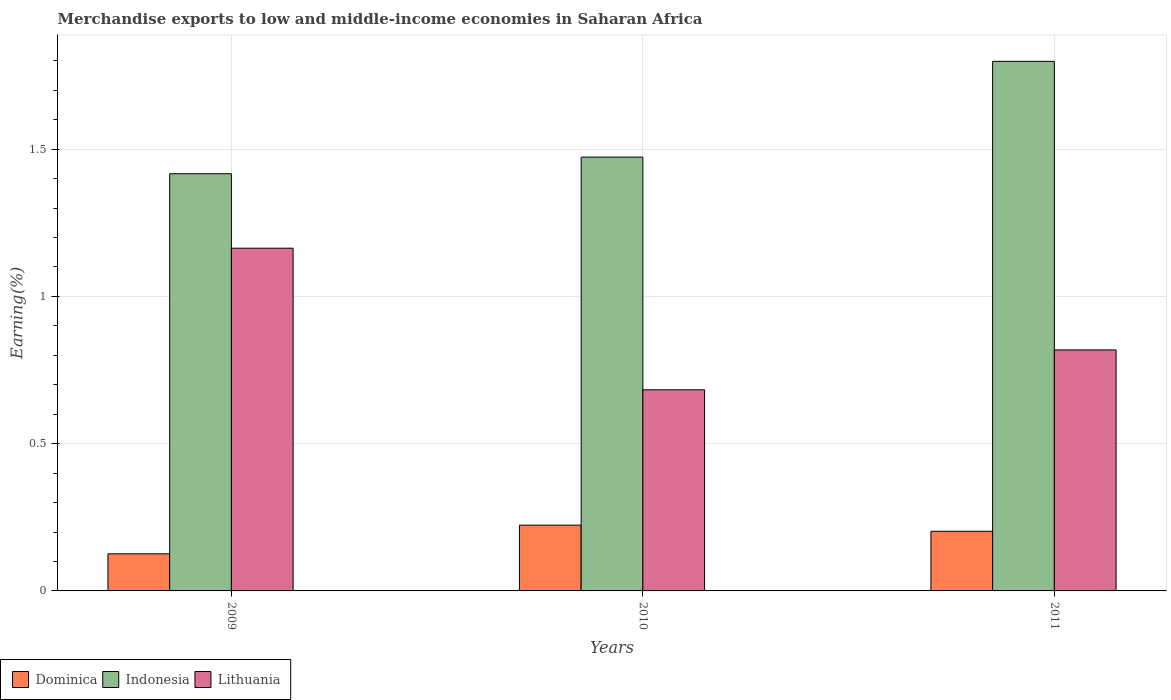How many different coloured bars are there?
Provide a succinct answer. 3. How many groups of bars are there?
Give a very brief answer. 3. Are the number of bars per tick equal to the number of legend labels?
Offer a terse response. Yes. Are the number of bars on each tick of the X-axis equal?
Offer a terse response. Yes. How many bars are there on the 1st tick from the left?
Ensure brevity in your answer.  3. How many bars are there on the 1st tick from the right?
Your answer should be compact. 3. What is the percentage of amount earned from merchandise exports in Indonesia in 2011?
Make the answer very short. 1.8. Across all years, what is the maximum percentage of amount earned from merchandise exports in Indonesia?
Give a very brief answer. 1.8. Across all years, what is the minimum percentage of amount earned from merchandise exports in Lithuania?
Ensure brevity in your answer.  0.68. In which year was the percentage of amount earned from merchandise exports in Indonesia minimum?
Offer a terse response. 2009. What is the total percentage of amount earned from merchandise exports in Lithuania in the graph?
Keep it short and to the point. 2.66. What is the difference between the percentage of amount earned from merchandise exports in Indonesia in 2009 and that in 2010?
Your answer should be compact. -0.06. What is the difference between the percentage of amount earned from merchandise exports in Lithuania in 2011 and the percentage of amount earned from merchandise exports in Indonesia in 2009?
Your answer should be compact. -0.6. What is the average percentage of amount earned from merchandise exports in Lithuania per year?
Offer a terse response. 0.89. In the year 2011, what is the difference between the percentage of amount earned from merchandise exports in Indonesia and percentage of amount earned from merchandise exports in Lithuania?
Your answer should be very brief. 0.98. In how many years, is the percentage of amount earned from merchandise exports in Dominica greater than 1.5 %?
Your answer should be very brief. 0. What is the ratio of the percentage of amount earned from merchandise exports in Dominica in 2010 to that in 2011?
Offer a terse response. 1.1. Is the percentage of amount earned from merchandise exports in Indonesia in 2010 less than that in 2011?
Offer a very short reply. Yes. Is the difference between the percentage of amount earned from merchandise exports in Indonesia in 2009 and 2010 greater than the difference between the percentage of amount earned from merchandise exports in Lithuania in 2009 and 2010?
Your response must be concise. No. What is the difference between the highest and the second highest percentage of amount earned from merchandise exports in Lithuania?
Provide a short and direct response. 0.35. What is the difference between the highest and the lowest percentage of amount earned from merchandise exports in Lithuania?
Offer a terse response. 0.48. Is the sum of the percentage of amount earned from merchandise exports in Lithuania in 2009 and 2010 greater than the maximum percentage of amount earned from merchandise exports in Indonesia across all years?
Give a very brief answer. Yes. What does the 1st bar from the left in 2009 represents?
Keep it short and to the point. Dominica. What does the 3rd bar from the right in 2011 represents?
Keep it short and to the point. Dominica. Does the graph contain any zero values?
Your answer should be compact. No. Where does the legend appear in the graph?
Your answer should be very brief. Bottom left. What is the title of the graph?
Provide a short and direct response. Merchandise exports to low and middle-income economies in Saharan Africa. Does "St. Martin (French part)" appear as one of the legend labels in the graph?
Keep it short and to the point. No. What is the label or title of the Y-axis?
Provide a succinct answer. Earning(%). What is the Earning(%) of Dominica in 2009?
Your response must be concise. 0.13. What is the Earning(%) in Indonesia in 2009?
Give a very brief answer. 1.42. What is the Earning(%) of Lithuania in 2009?
Your answer should be compact. 1.16. What is the Earning(%) in Dominica in 2010?
Provide a short and direct response. 0.22. What is the Earning(%) in Indonesia in 2010?
Keep it short and to the point. 1.47. What is the Earning(%) in Lithuania in 2010?
Provide a short and direct response. 0.68. What is the Earning(%) in Dominica in 2011?
Your answer should be very brief. 0.2. What is the Earning(%) of Indonesia in 2011?
Your response must be concise. 1.8. What is the Earning(%) of Lithuania in 2011?
Your answer should be compact. 0.82. Across all years, what is the maximum Earning(%) in Dominica?
Ensure brevity in your answer.  0.22. Across all years, what is the maximum Earning(%) of Indonesia?
Offer a terse response. 1.8. Across all years, what is the maximum Earning(%) of Lithuania?
Make the answer very short. 1.16. Across all years, what is the minimum Earning(%) in Dominica?
Give a very brief answer. 0.13. Across all years, what is the minimum Earning(%) in Indonesia?
Provide a short and direct response. 1.42. Across all years, what is the minimum Earning(%) in Lithuania?
Make the answer very short. 0.68. What is the total Earning(%) of Dominica in the graph?
Your response must be concise. 0.55. What is the total Earning(%) in Indonesia in the graph?
Your answer should be compact. 4.69. What is the total Earning(%) of Lithuania in the graph?
Make the answer very short. 2.66. What is the difference between the Earning(%) in Dominica in 2009 and that in 2010?
Provide a short and direct response. -0.1. What is the difference between the Earning(%) in Indonesia in 2009 and that in 2010?
Offer a very short reply. -0.06. What is the difference between the Earning(%) of Lithuania in 2009 and that in 2010?
Give a very brief answer. 0.48. What is the difference between the Earning(%) in Dominica in 2009 and that in 2011?
Offer a very short reply. -0.08. What is the difference between the Earning(%) of Indonesia in 2009 and that in 2011?
Ensure brevity in your answer.  -0.38. What is the difference between the Earning(%) of Lithuania in 2009 and that in 2011?
Make the answer very short. 0.35. What is the difference between the Earning(%) in Dominica in 2010 and that in 2011?
Give a very brief answer. 0.02. What is the difference between the Earning(%) in Indonesia in 2010 and that in 2011?
Offer a very short reply. -0.33. What is the difference between the Earning(%) in Lithuania in 2010 and that in 2011?
Ensure brevity in your answer.  -0.14. What is the difference between the Earning(%) of Dominica in 2009 and the Earning(%) of Indonesia in 2010?
Provide a succinct answer. -1.35. What is the difference between the Earning(%) of Dominica in 2009 and the Earning(%) of Lithuania in 2010?
Your answer should be very brief. -0.56. What is the difference between the Earning(%) of Indonesia in 2009 and the Earning(%) of Lithuania in 2010?
Provide a short and direct response. 0.73. What is the difference between the Earning(%) of Dominica in 2009 and the Earning(%) of Indonesia in 2011?
Keep it short and to the point. -1.67. What is the difference between the Earning(%) in Dominica in 2009 and the Earning(%) in Lithuania in 2011?
Provide a short and direct response. -0.69. What is the difference between the Earning(%) in Indonesia in 2009 and the Earning(%) in Lithuania in 2011?
Your answer should be very brief. 0.6. What is the difference between the Earning(%) in Dominica in 2010 and the Earning(%) in Indonesia in 2011?
Your answer should be very brief. -1.57. What is the difference between the Earning(%) of Dominica in 2010 and the Earning(%) of Lithuania in 2011?
Your answer should be very brief. -0.6. What is the difference between the Earning(%) in Indonesia in 2010 and the Earning(%) in Lithuania in 2011?
Offer a very short reply. 0.65. What is the average Earning(%) of Dominica per year?
Keep it short and to the point. 0.18. What is the average Earning(%) of Indonesia per year?
Offer a terse response. 1.56. What is the average Earning(%) in Lithuania per year?
Offer a very short reply. 0.89. In the year 2009, what is the difference between the Earning(%) in Dominica and Earning(%) in Indonesia?
Make the answer very short. -1.29. In the year 2009, what is the difference between the Earning(%) of Dominica and Earning(%) of Lithuania?
Your answer should be very brief. -1.04. In the year 2009, what is the difference between the Earning(%) of Indonesia and Earning(%) of Lithuania?
Offer a terse response. 0.25. In the year 2010, what is the difference between the Earning(%) in Dominica and Earning(%) in Indonesia?
Provide a succinct answer. -1.25. In the year 2010, what is the difference between the Earning(%) of Dominica and Earning(%) of Lithuania?
Your answer should be very brief. -0.46. In the year 2010, what is the difference between the Earning(%) in Indonesia and Earning(%) in Lithuania?
Make the answer very short. 0.79. In the year 2011, what is the difference between the Earning(%) of Dominica and Earning(%) of Indonesia?
Your answer should be compact. -1.6. In the year 2011, what is the difference between the Earning(%) in Dominica and Earning(%) in Lithuania?
Give a very brief answer. -0.62. In the year 2011, what is the difference between the Earning(%) of Indonesia and Earning(%) of Lithuania?
Provide a succinct answer. 0.98. What is the ratio of the Earning(%) in Dominica in 2009 to that in 2010?
Your answer should be compact. 0.56. What is the ratio of the Earning(%) in Indonesia in 2009 to that in 2010?
Give a very brief answer. 0.96. What is the ratio of the Earning(%) of Lithuania in 2009 to that in 2010?
Offer a terse response. 1.7. What is the ratio of the Earning(%) of Dominica in 2009 to that in 2011?
Provide a short and direct response. 0.62. What is the ratio of the Earning(%) in Indonesia in 2009 to that in 2011?
Keep it short and to the point. 0.79. What is the ratio of the Earning(%) in Lithuania in 2009 to that in 2011?
Your answer should be compact. 1.42. What is the ratio of the Earning(%) of Dominica in 2010 to that in 2011?
Your response must be concise. 1.1. What is the ratio of the Earning(%) of Indonesia in 2010 to that in 2011?
Offer a very short reply. 0.82. What is the ratio of the Earning(%) in Lithuania in 2010 to that in 2011?
Offer a very short reply. 0.83. What is the difference between the highest and the second highest Earning(%) in Dominica?
Offer a very short reply. 0.02. What is the difference between the highest and the second highest Earning(%) in Indonesia?
Your answer should be very brief. 0.33. What is the difference between the highest and the second highest Earning(%) in Lithuania?
Your answer should be very brief. 0.35. What is the difference between the highest and the lowest Earning(%) in Dominica?
Keep it short and to the point. 0.1. What is the difference between the highest and the lowest Earning(%) of Indonesia?
Your answer should be compact. 0.38. What is the difference between the highest and the lowest Earning(%) of Lithuania?
Your answer should be very brief. 0.48. 